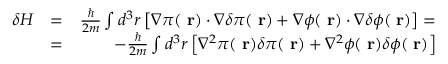Convert formula to latex. <formula><loc_0><loc_0><loc_500><loc_500>\begin{array} { r l r } { \delta H } & { = } & { \frac { } { 2 m } \int d ^ { 3 } r \left [ \nabla \pi ( r ) \cdot \nabla \delta \pi ( r ) + \nabla \phi ( r ) \cdot \nabla \delta \phi ( r ) \right ] = } \\ & { = } & { - \frac { } { 2 m } \int d ^ { 3 } r \left [ \nabla ^ { 2 } \pi ( r ) \delta \pi ( r ) + \nabla ^ { 2 } \phi ( r ) \delta \phi ( r ) \right ] } \end{array}</formula> 